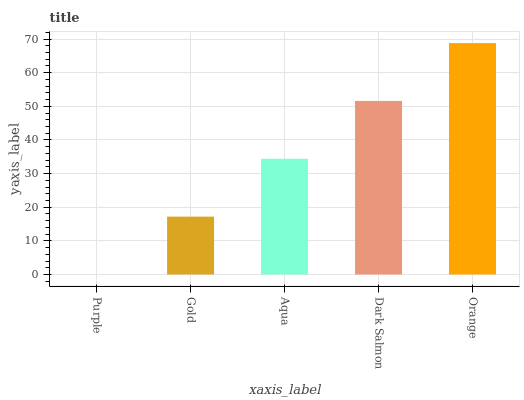Is Purple the minimum?
Answer yes or no. Yes. Is Orange the maximum?
Answer yes or no. Yes. Is Gold the minimum?
Answer yes or no. No. Is Gold the maximum?
Answer yes or no. No. Is Gold greater than Purple?
Answer yes or no. Yes. Is Purple less than Gold?
Answer yes or no. Yes. Is Purple greater than Gold?
Answer yes or no. No. Is Gold less than Purple?
Answer yes or no. No. Is Aqua the high median?
Answer yes or no. Yes. Is Aqua the low median?
Answer yes or no. Yes. Is Orange the high median?
Answer yes or no. No. Is Purple the low median?
Answer yes or no. No. 